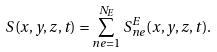<formula> <loc_0><loc_0><loc_500><loc_500>S ( x , y , z , t ) = \sum _ { n e = 1 } ^ { N _ { E } } S ^ { E } _ { n e } ( x , y , z , t ) .</formula> 